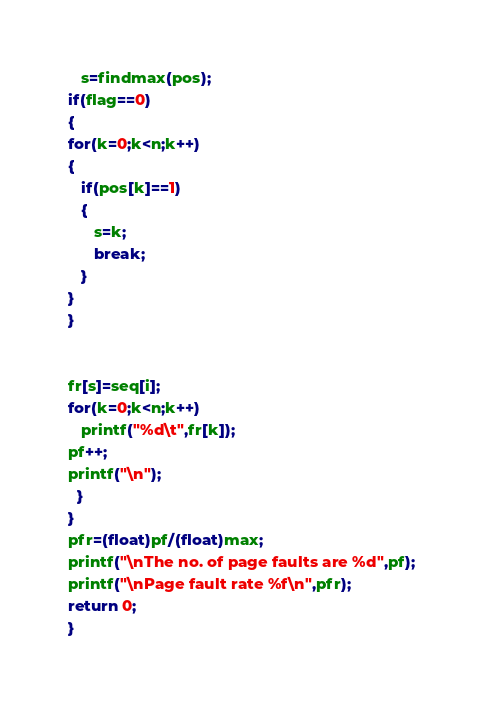<code> <loc_0><loc_0><loc_500><loc_500><_C_>   s=findmax(pos);
if(flag==0)
{
for(k=0;k<n;k++)
{
   if(pos[k]==1)
   {
      s=k;
      break;
   }
}
}


fr[s]=seq[i];
for(k=0;k<n;k++)
   printf("%d\t",fr[k]);
pf++;
printf("\n");
  }
} 
pfr=(float)pf/(float)max;
printf("\nThe no. of page faults are %d",pf);
printf("\nPage fault rate %f\n",pfr);
return 0;
}</code> 